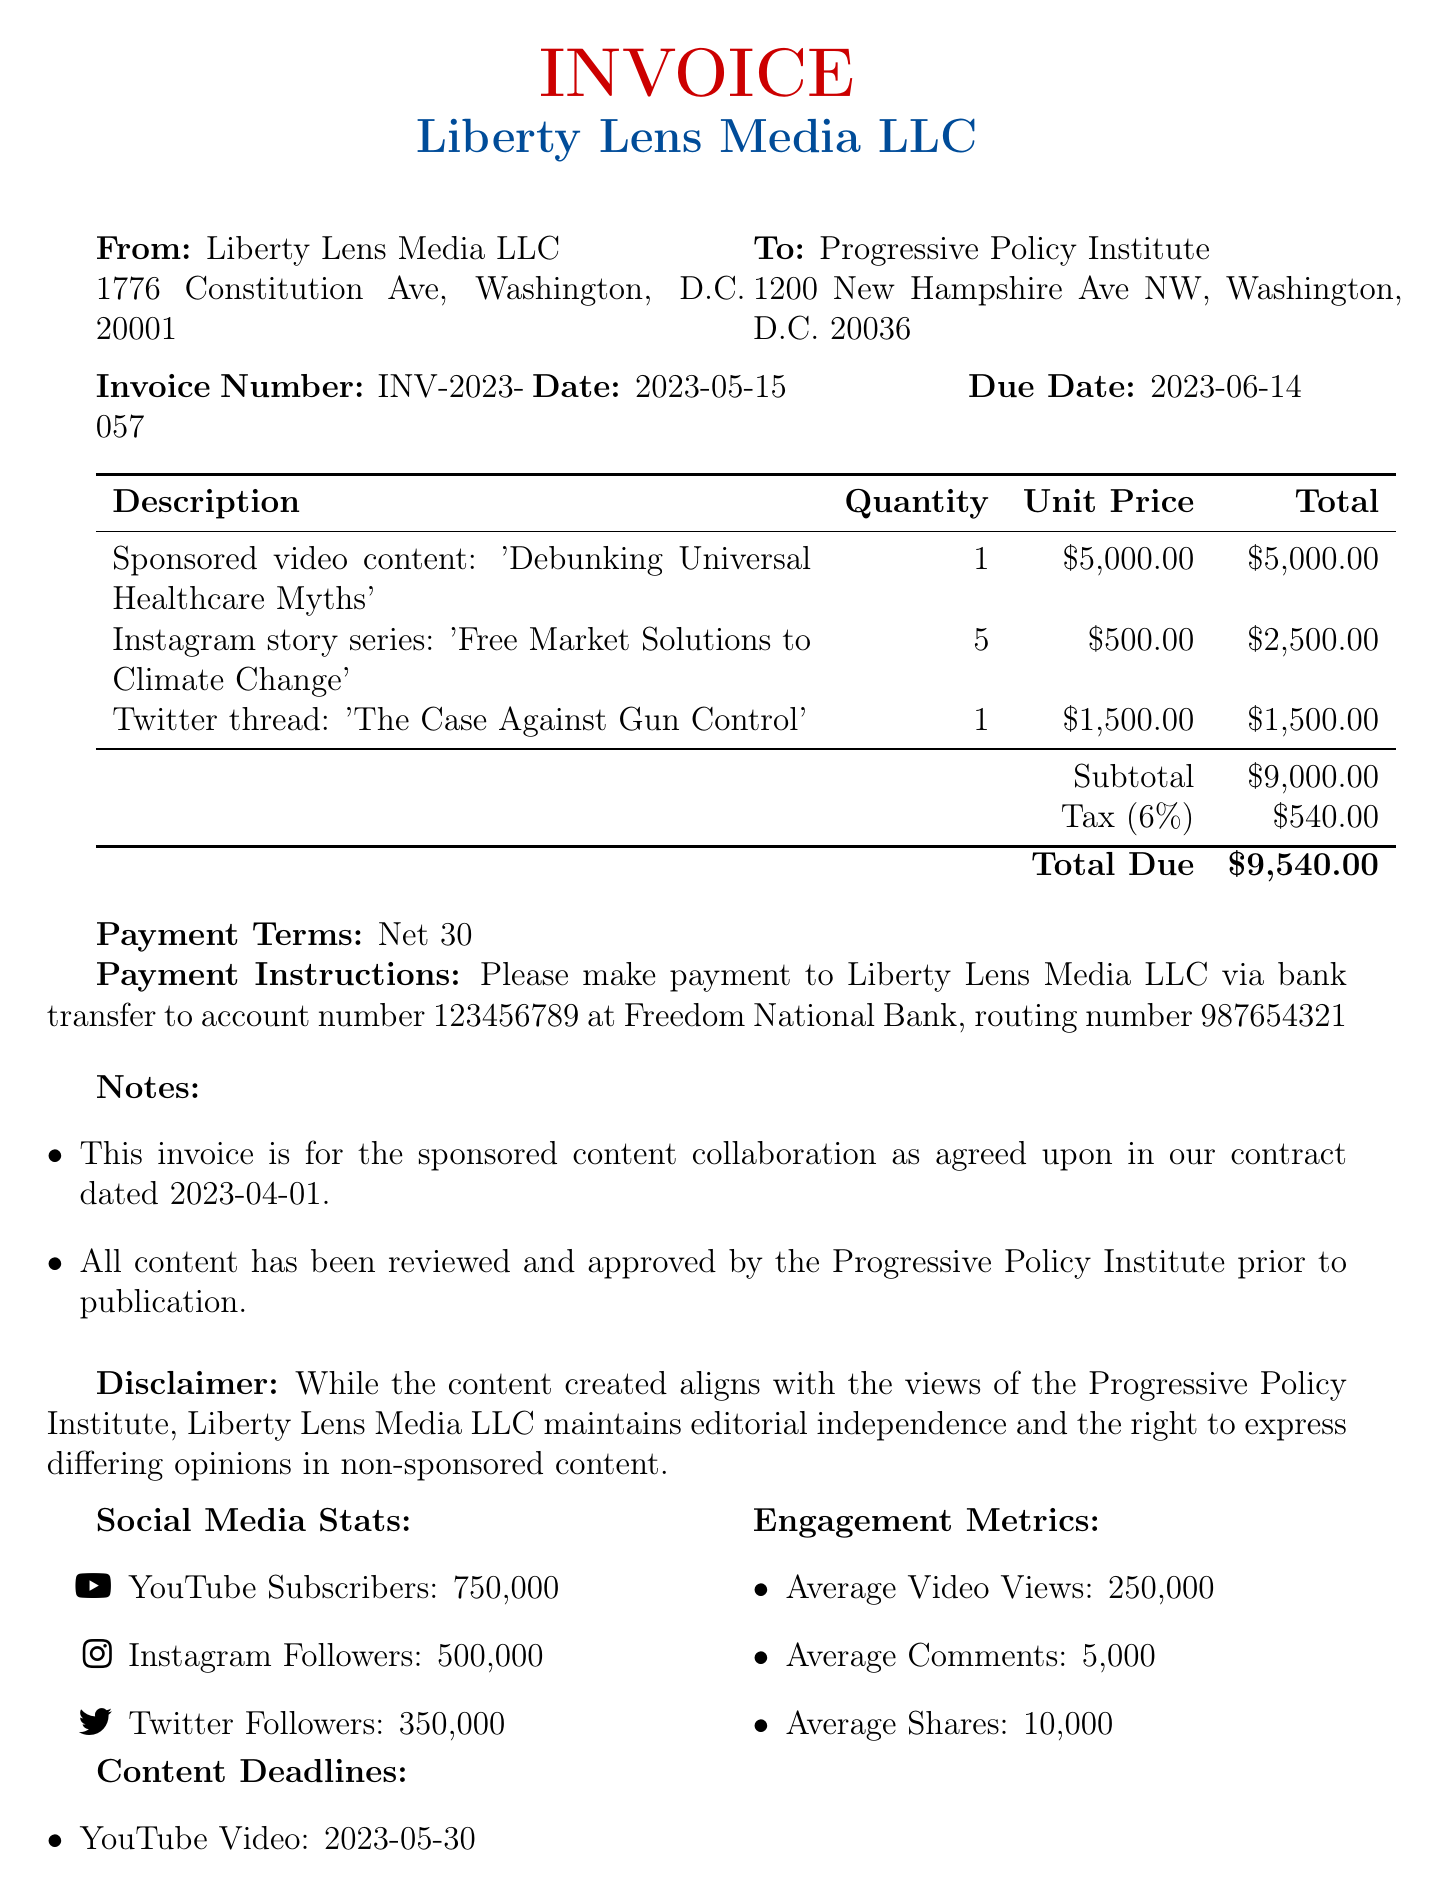what is the invoice number? The invoice number can be found in the header section of the document.
Answer: INV-2023-057 who is the sender of the invoice? The sender of the invoice is listed in the 'From' section at the top of the document.
Answer: Liberty Lens Media LLC what is the due date for payment? The due date is specified along with the invoice date in the document.
Answer: 2023-06-14 how much is the tax amount? The tax amount is calculated based on the subtotal and is detailed in the charges section of the document.
Answer: 540 what is the total amount due? The total is at the bottom of the invoice, summarizing the charges, tax, and any adjustments.
Answer: 9540 how many Instagram stories are included in the collaboration? The quantity of Instagram stories is listed in the items section of the invoice under the description.
Answer: 5 what is the payment term specified in the document? The payment term is located in the payment section of the invoice.
Answer: Net 30 when is the deadline for the YouTube video content? The deadline is mentioned under the content deadlines section of the document.
Answer: 2023-05-30 what is stated in the disclaimer? The disclaimer is provided at the end of the document, summarizing the editorial independence of Liberty Lens Media LLC.
Answer: While the content created aligns with the views of the Progressive Policy Institute, Liberty Lens Media LLC maintains editorial independence and the right to express differing opinions in non-sponsored content 